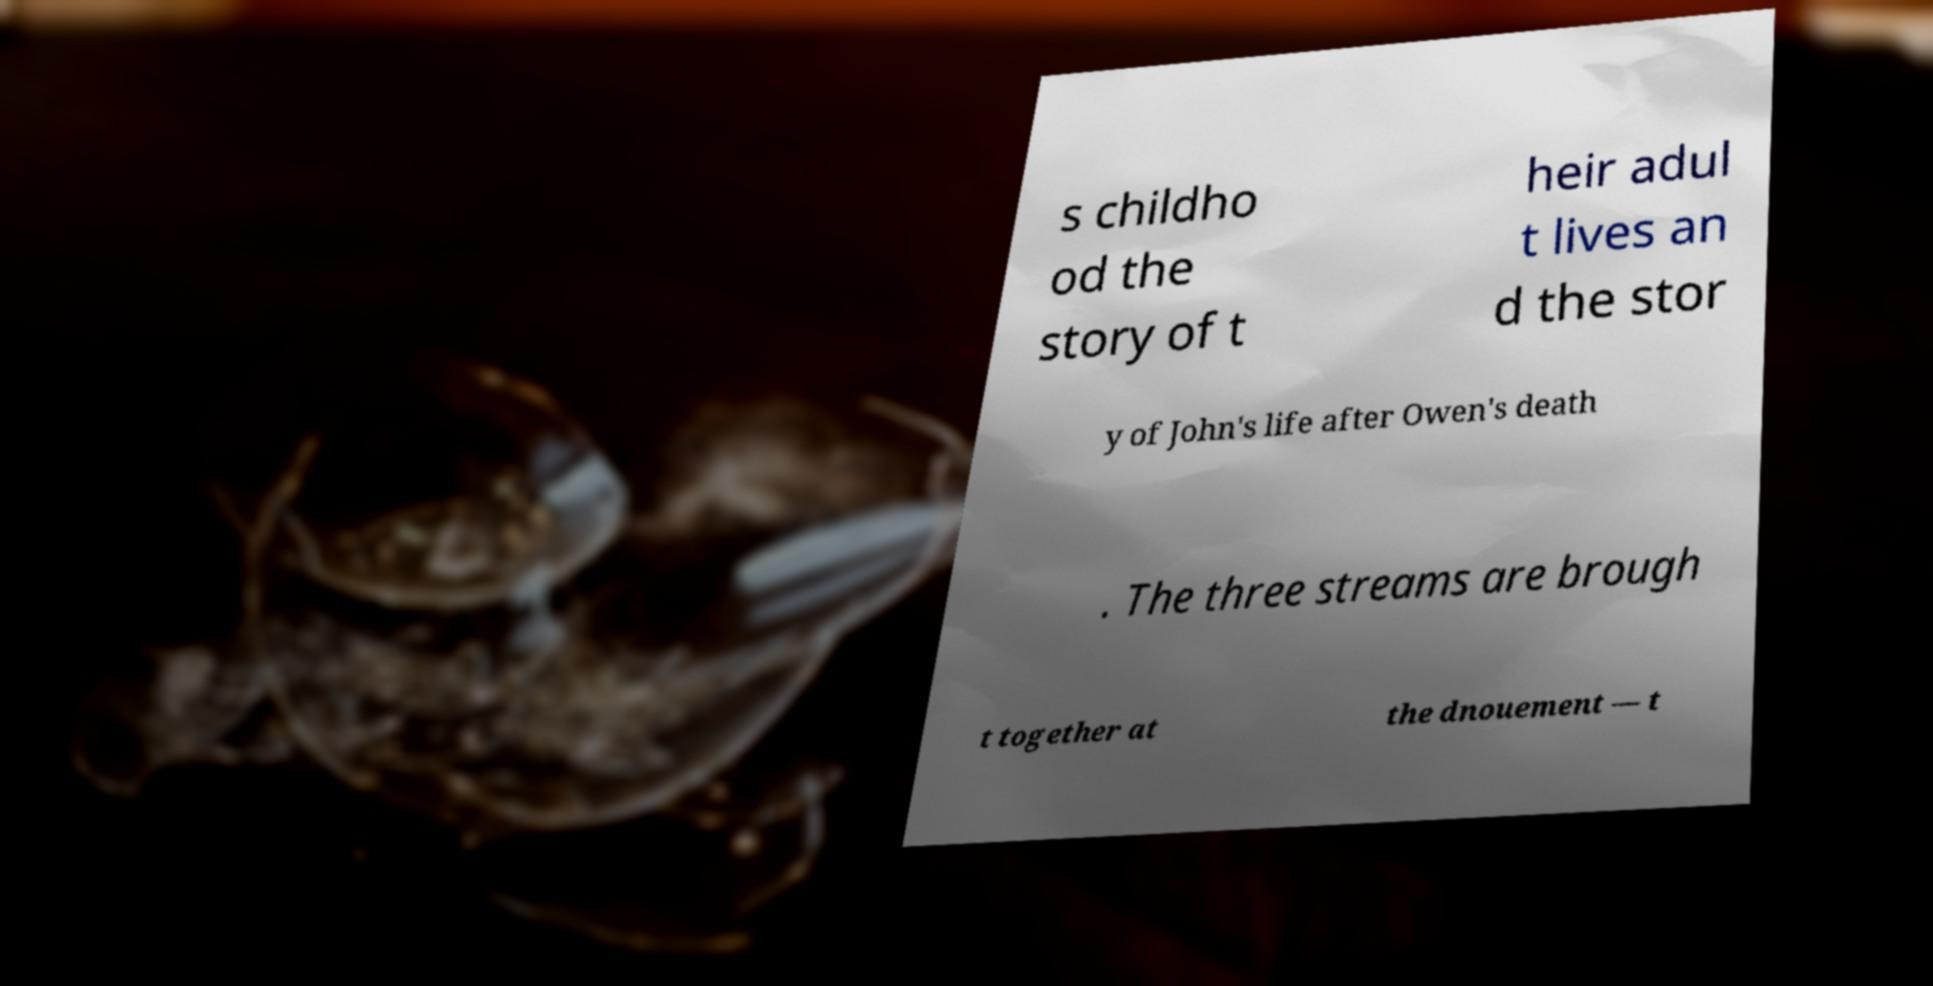Could you assist in decoding the text presented in this image and type it out clearly? s childho od the story of t heir adul t lives an d the stor y of John's life after Owen's death . The three streams are brough t together at the dnouement — t 